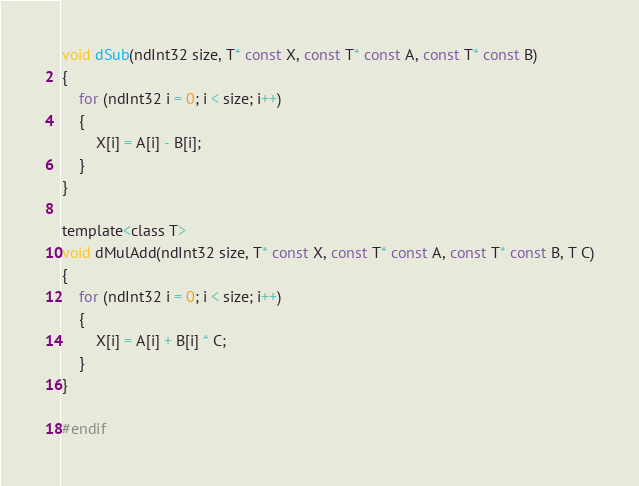Convert code to text. <code><loc_0><loc_0><loc_500><loc_500><_C_>void dSub(ndInt32 size, T* const X, const T* const A, const T* const B)
{
	for (ndInt32 i = 0; i < size; i++) 
	{
		X[i] = A[i] - B[i];
	}
}

template<class T>
void dMulAdd(ndInt32 size, T* const X, const T* const A, const T* const B, T C)
{
	for (ndInt32 i = 0; i < size; i++) 
	{
		X[i] = A[i] + B[i] * C;
	}
}

#endif


</code> 